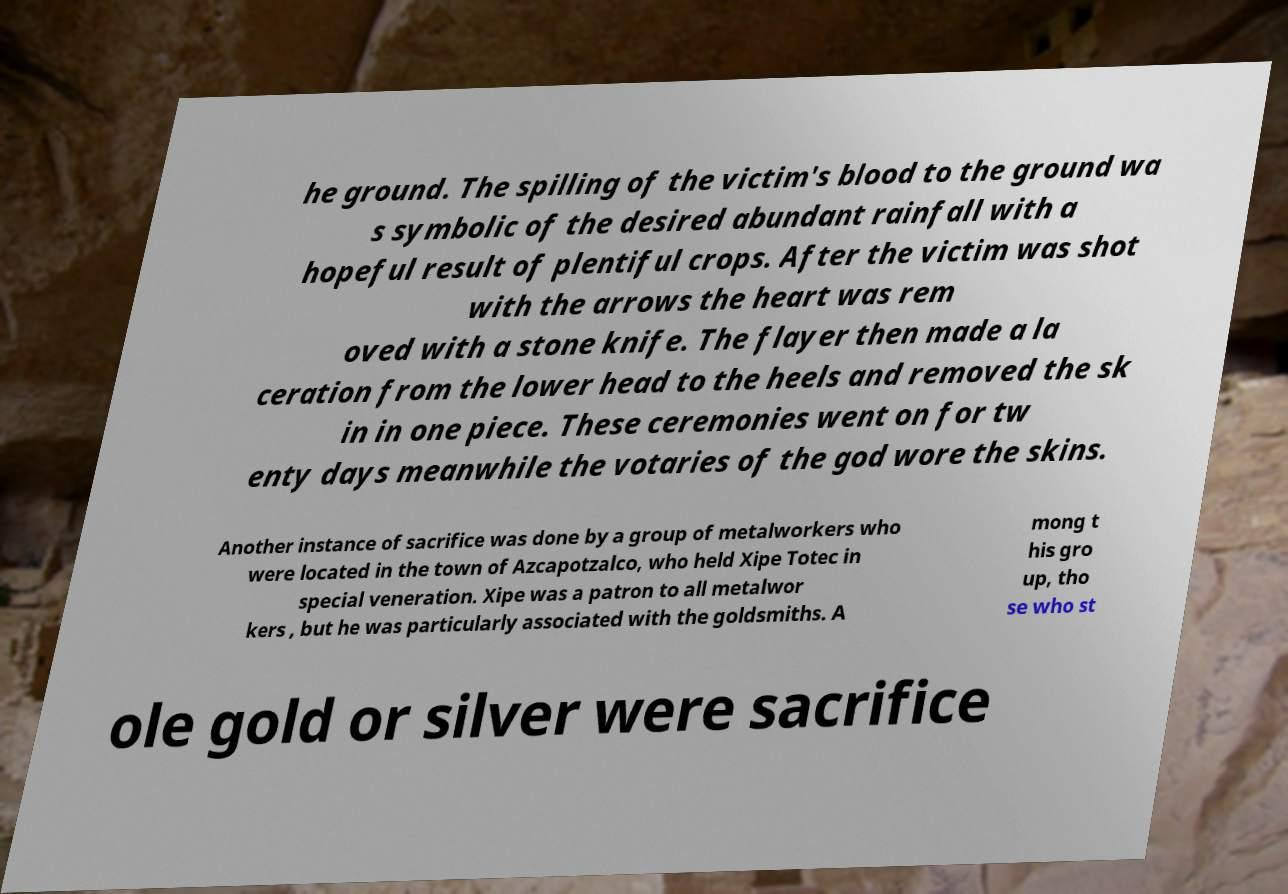Could you extract and type out the text from this image? he ground. The spilling of the victim's blood to the ground wa s symbolic of the desired abundant rainfall with a hopeful result of plentiful crops. After the victim was shot with the arrows the heart was rem oved with a stone knife. The flayer then made a la ceration from the lower head to the heels and removed the sk in in one piece. These ceremonies went on for tw enty days meanwhile the votaries of the god wore the skins. Another instance of sacrifice was done by a group of metalworkers who were located in the town of Azcapotzalco, who held Xipe Totec in special veneration. Xipe was a patron to all metalwor kers , but he was particularly associated with the goldsmiths. A mong t his gro up, tho se who st ole gold or silver were sacrifice 